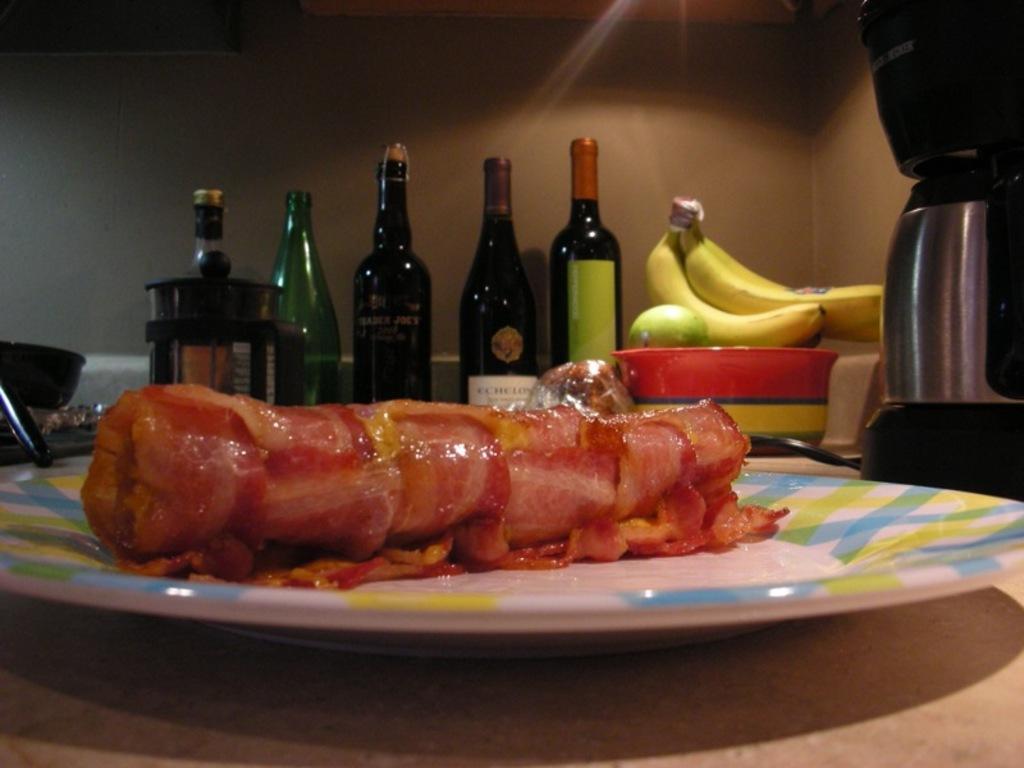How would you summarize this image in a sentence or two? In this image I see few bottles, a banana and food in the plate. 